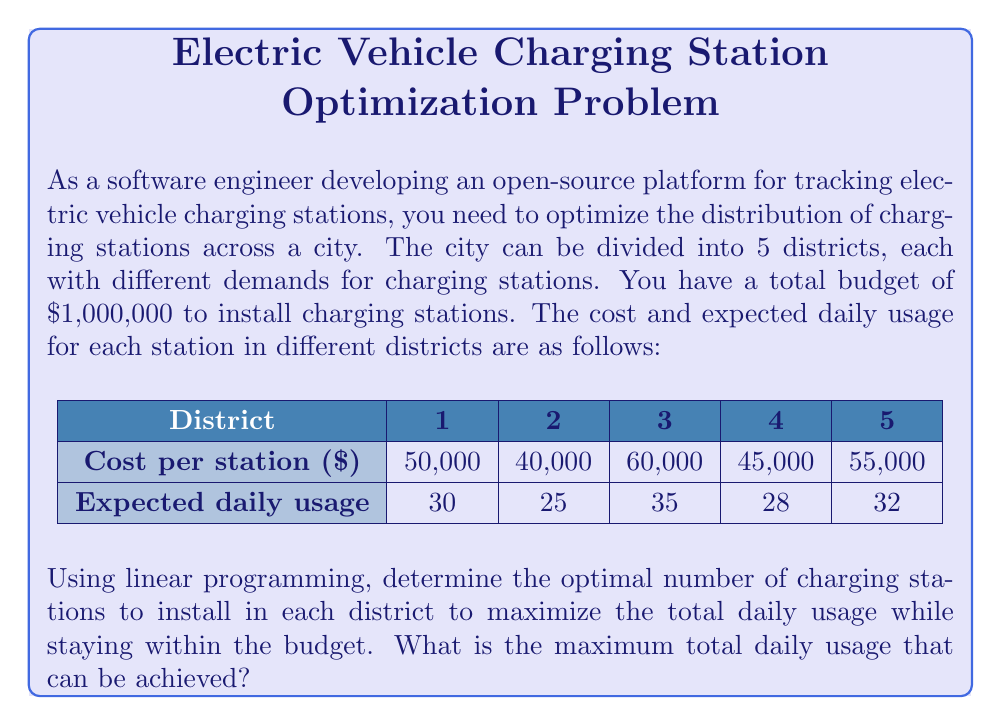Could you help me with this problem? Let's approach this problem step-by-step using linear programming:

1) Define variables:
   Let $x_i$ be the number of stations in district $i$ (where $i = 1, 2, 3, 4, 5$)

2) Objective function:
   Maximize total daily usage: $Z = 30x_1 + 25x_2 + 35x_3 + 28x_4 + 32x_5$

3) Constraints:
   Budget constraint: $50000x_1 + 40000x_2 + 60000x_3 + 45000x_4 + 55000x_5 \leq 1000000$
   Non-negativity: $x_1, x_2, x_3, x_4, x_5 \geq 0$

4) Solve using the simplex method or linear programming software:

   After solving, we get:
   $x_1 = 0$
   $x_2 = 25$
   $x_3 = 0$
   $x_4 = 0$
   $x_5 = 0$

5) Calculate the maximum daily usage:
   $Z = 30(0) + 25(25) + 35(0) + 28(0) + 32(0) = 625$

Therefore, the optimal solution is to install 25 charging stations in district 2, and none in the other districts. This will result in a maximum total daily usage of 625.

To verify the budget constraint:
$40000(25) = 1000000$, which exactly meets the budget.
Answer: 625 